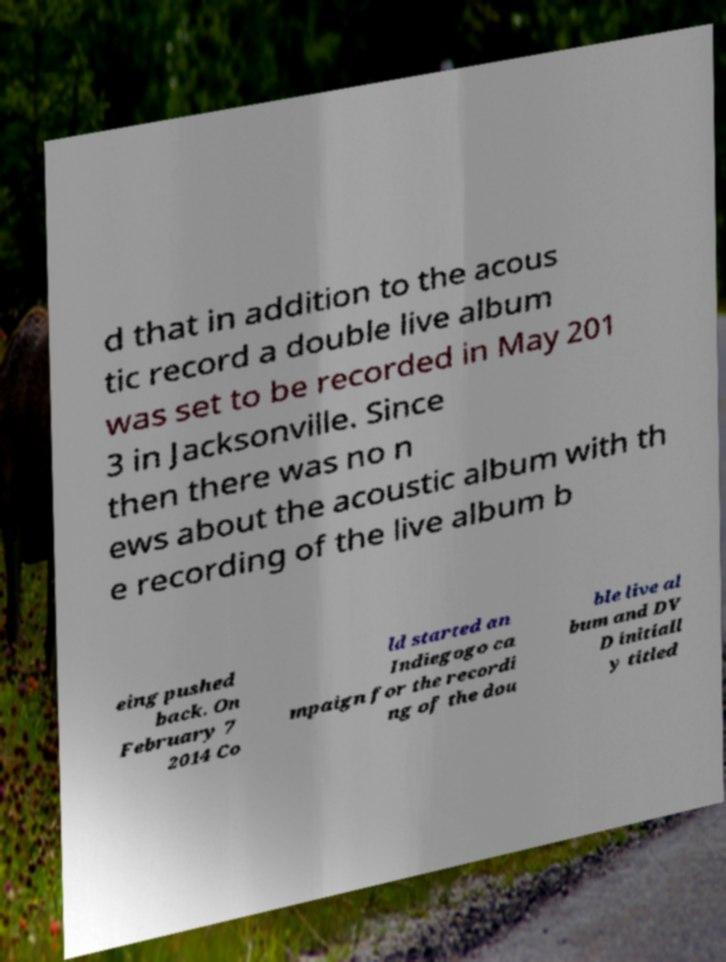Please read and relay the text visible in this image. What does it say? d that in addition to the acous tic record a double live album was set to be recorded in May 201 3 in Jacksonville. Since then there was no n ews about the acoustic album with th e recording of the live album b eing pushed back. On February 7 2014 Co ld started an Indiegogo ca mpaign for the recordi ng of the dou ble live al bum and DV D initiall y titled 